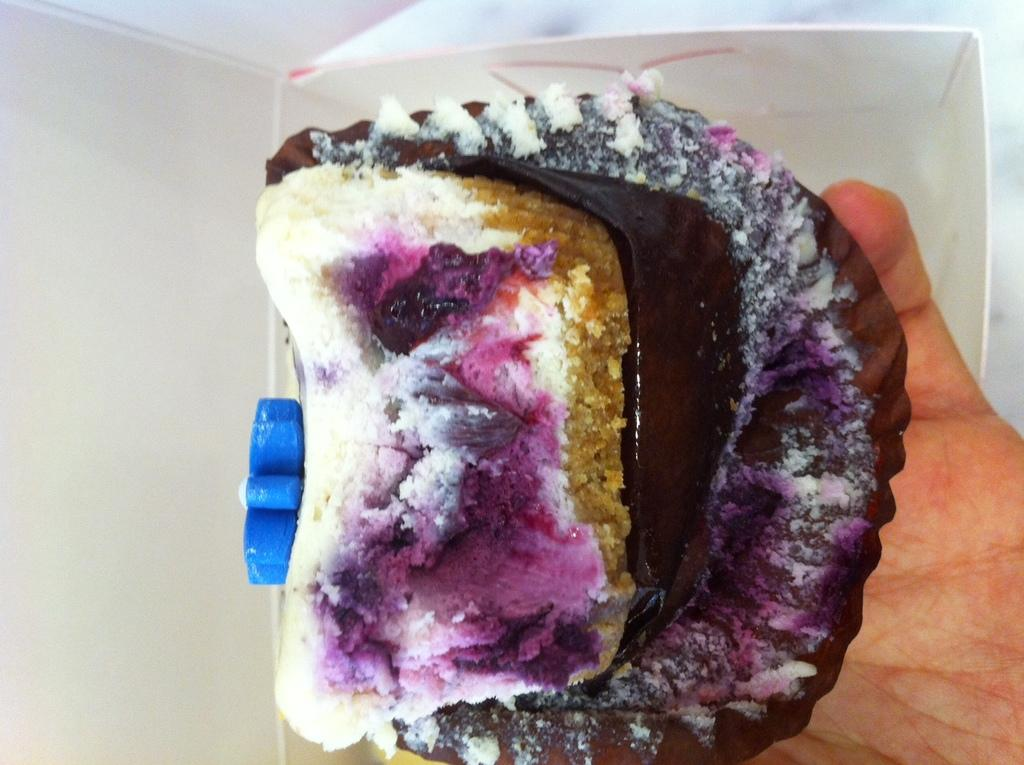What is the person's hand holding in the image? There is a person's hand holding a food item in the image. What else can be seen in the image besides the hand and food item? There is a white box visible in the image. What type of expert is visible on the moon in the image? There is no expert or moon present in the image; it only features a person's hand holding a food item and a white box. 